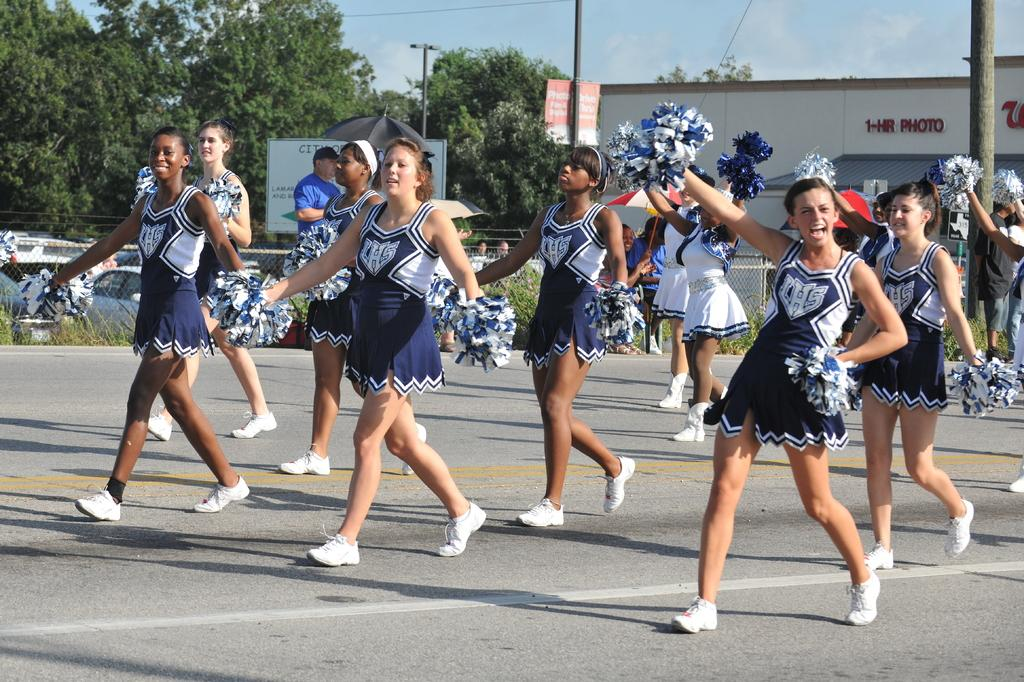What is happening in the image? There is a group of women walking on the road. What can be seen in the background of the image? In the background, there is fencing, cars, at least one person, trees, a building, a board, a ski, poles, and clouds. How many women are in the group? The number of women in the group is not specified, but there is a group of women in the image. What type of head is visible on the bird in the image? There is no bird present in the image, so it is not possible to answer that question. 